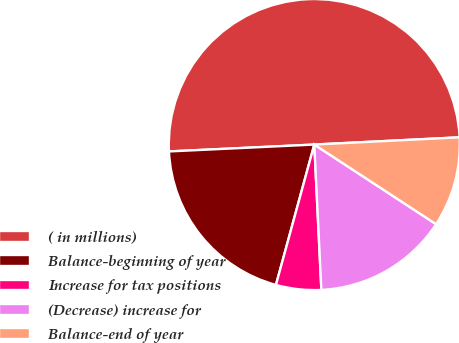Convert chart to OTSL. <chart><loc_0><loc_0><loc_500><loc_500><pie_chart><fcel>( in millions)<fcel>Balance-beginning of year<fcel>Increase for tax positions<fcel>(Decrease) increase for<fcel>Balance-end of year<nl><fcel>49.96%<fcel>20.0%<fcel>5.02%<fcel>15.01%<fcel>10.01%<nl></chart> 